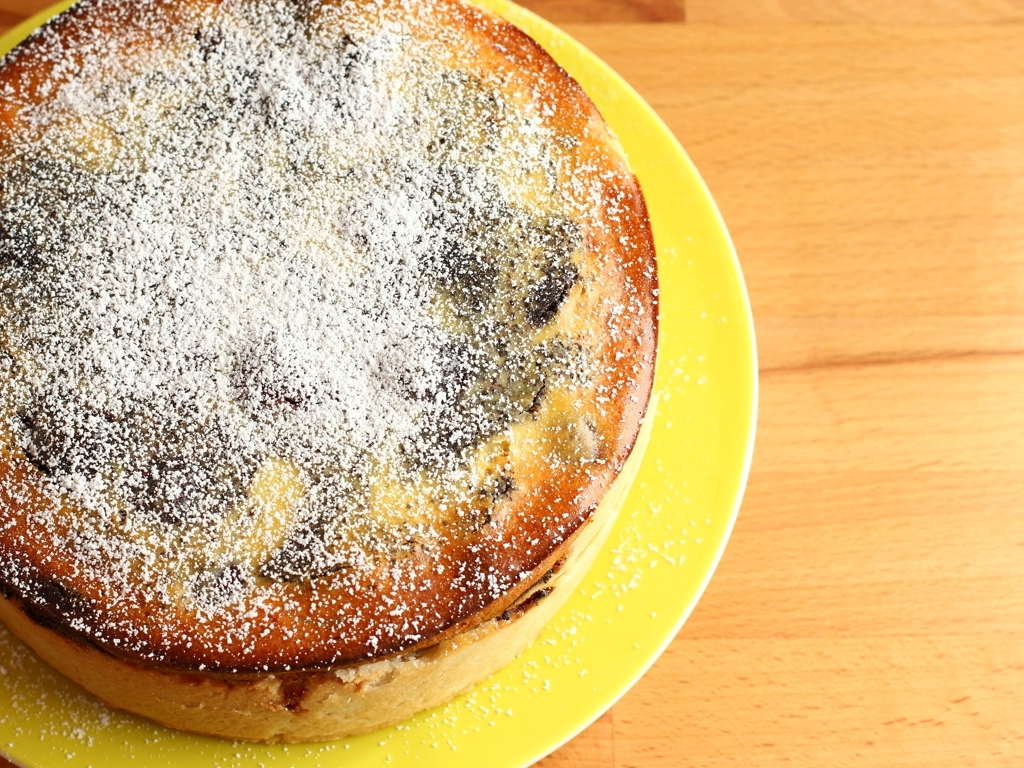What kind of cake is this, and can you describe its texture and possible flavor? This appears to be a sponge cake with a light golden-brown crust and a dusting of powdered sugar on top. The texture likely is soft and moist, with a delicate crumb that suggests a buttery, mildly sweet flavor, perhaps with hints of vanilla or citrus if present in the recipe. 